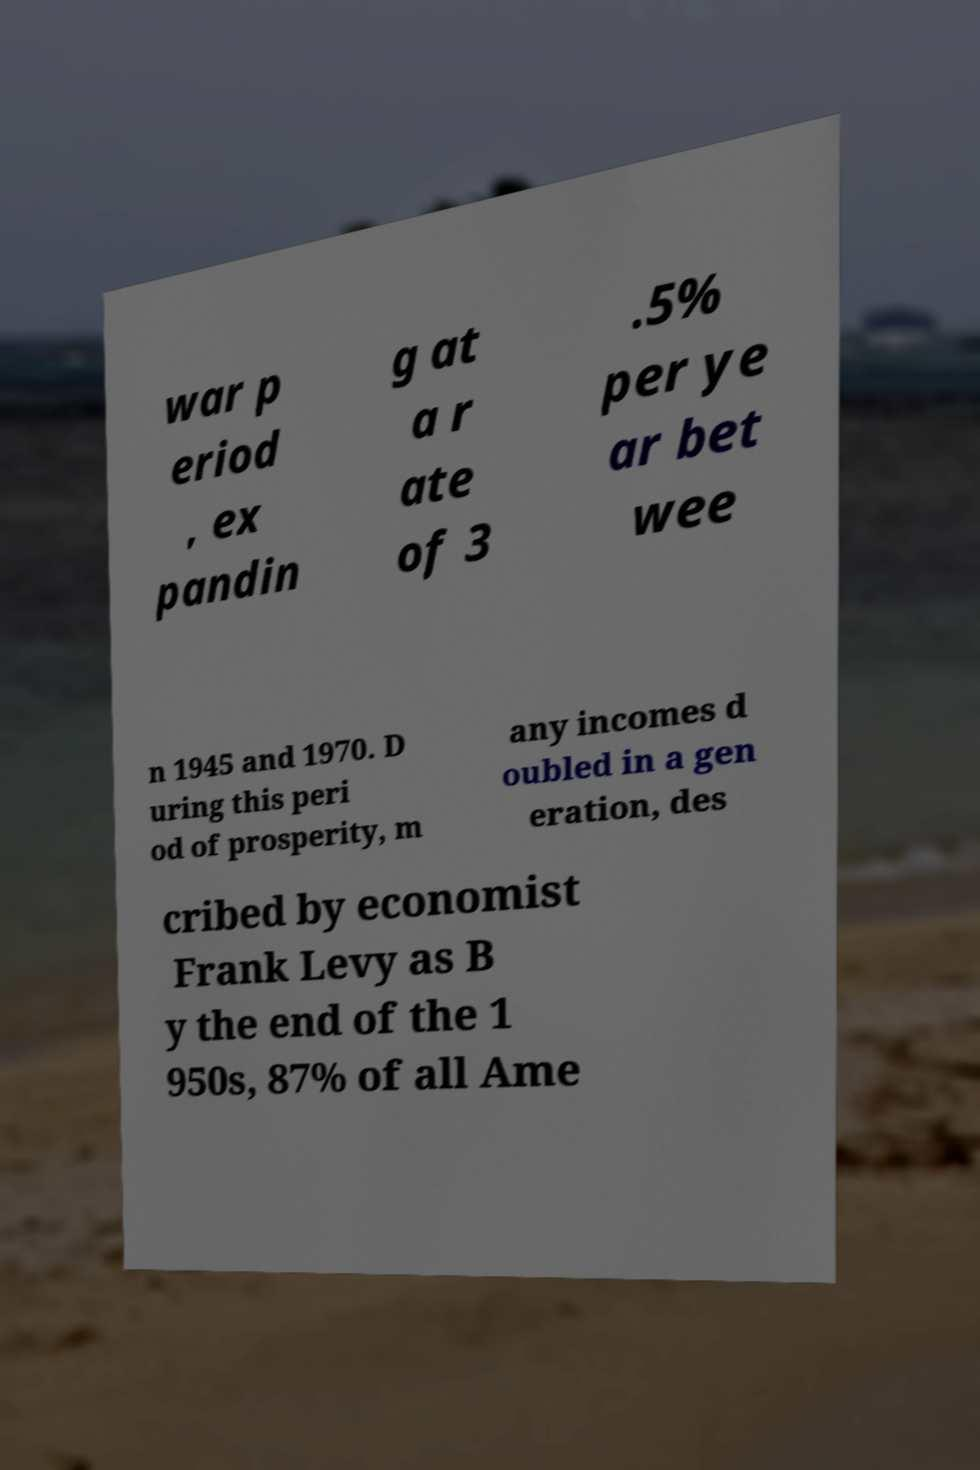Could you assist in decoding the text presented in this image and type it out clearly? war p eriod , ex pandin g at a r ate of 3 .5% per ye ar bet wee n 1945 and 1970. D uring this peri od of prosperity, m any incomes d oubled in a gen eration, des cribed by economist Frank Levy as B y the end of the 1 950s, 87% of all Ame 